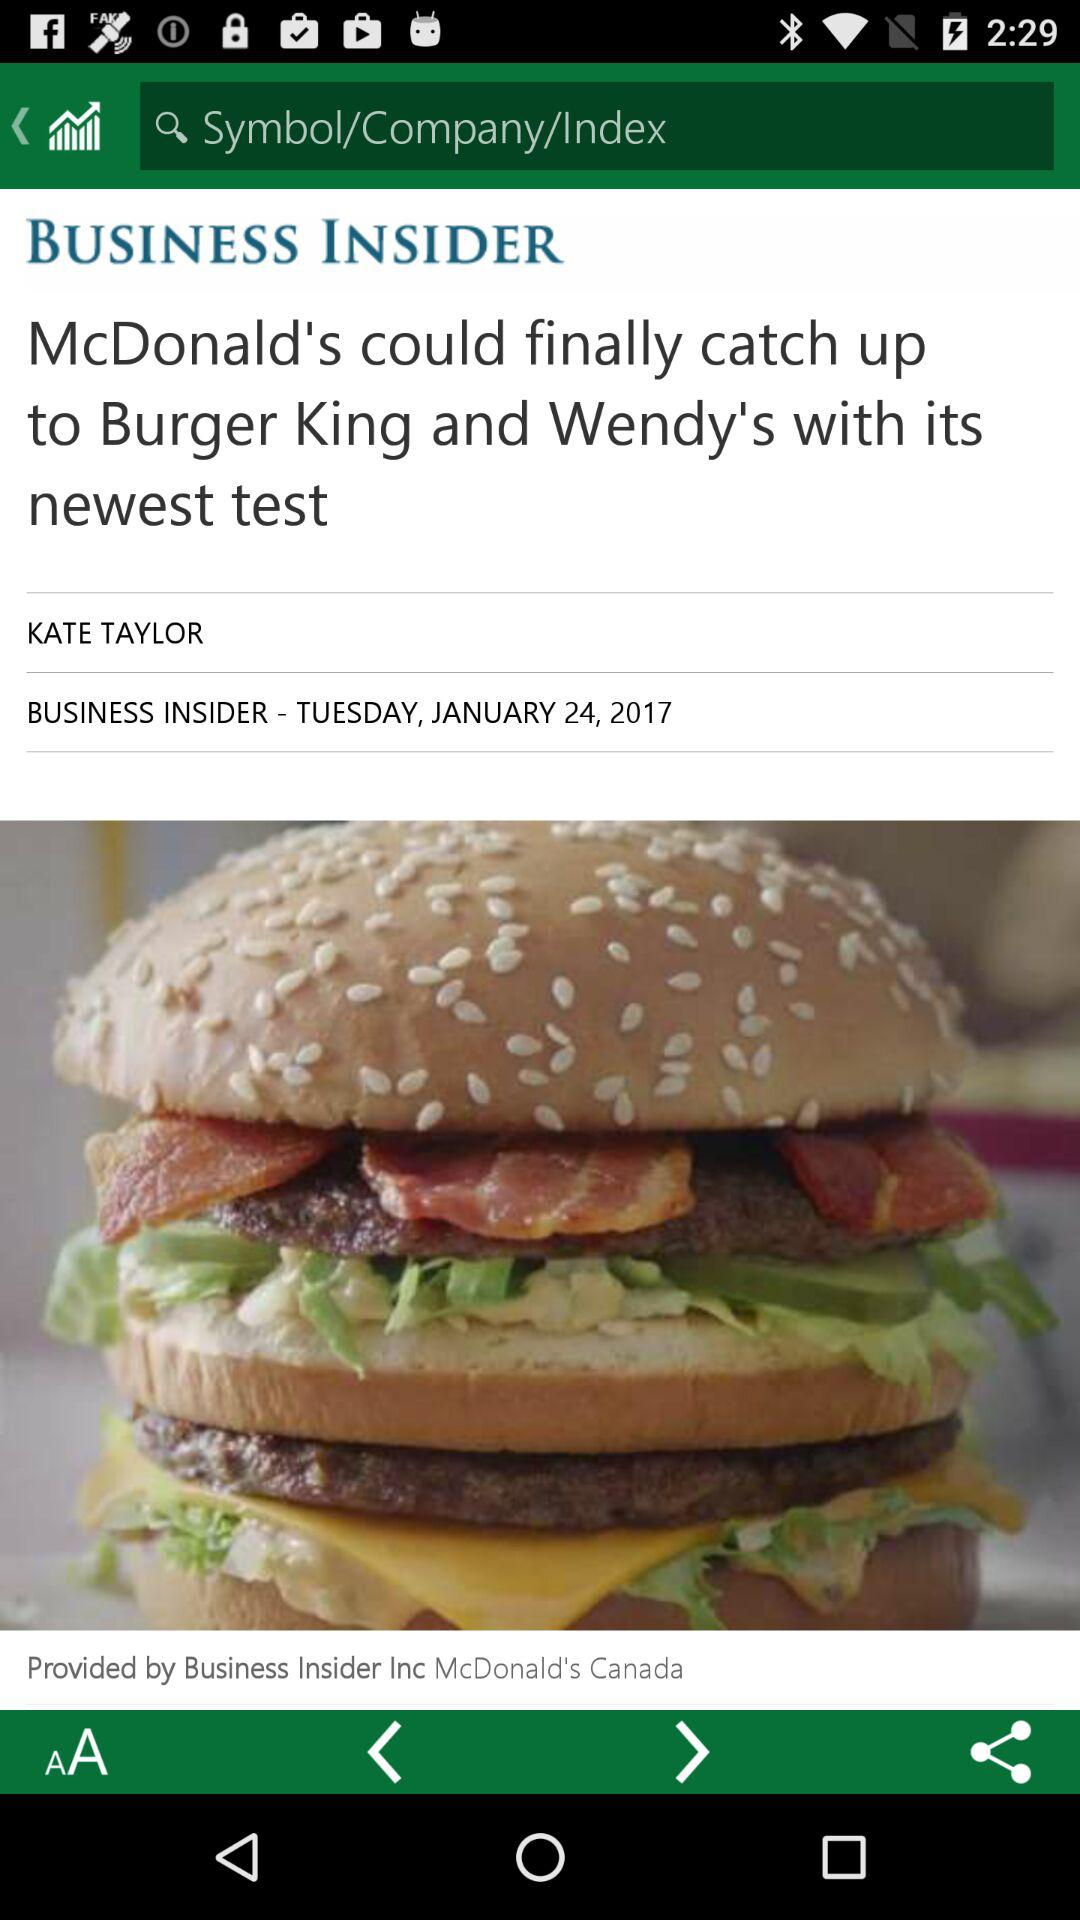Who is the author? The author is Kate Taylor. 